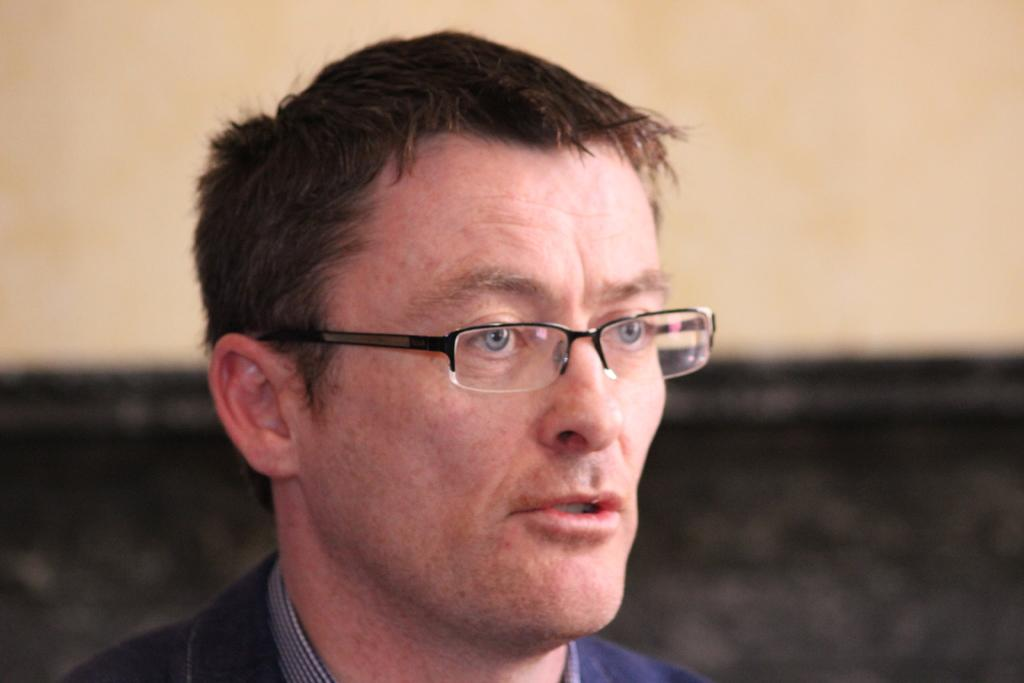Who is the main subject in the image? There is a man in the center of the image. What is the man wearing in the image? The man is wearing glasses in the image. What can be seen in the background of the image? There is a wall in the background of the image. How many fish can be seen swimming near the man in the image? There are no fish present in the image. What type of game is the man playing in the image? There is no game being played in the image; the man is simply standing there. 